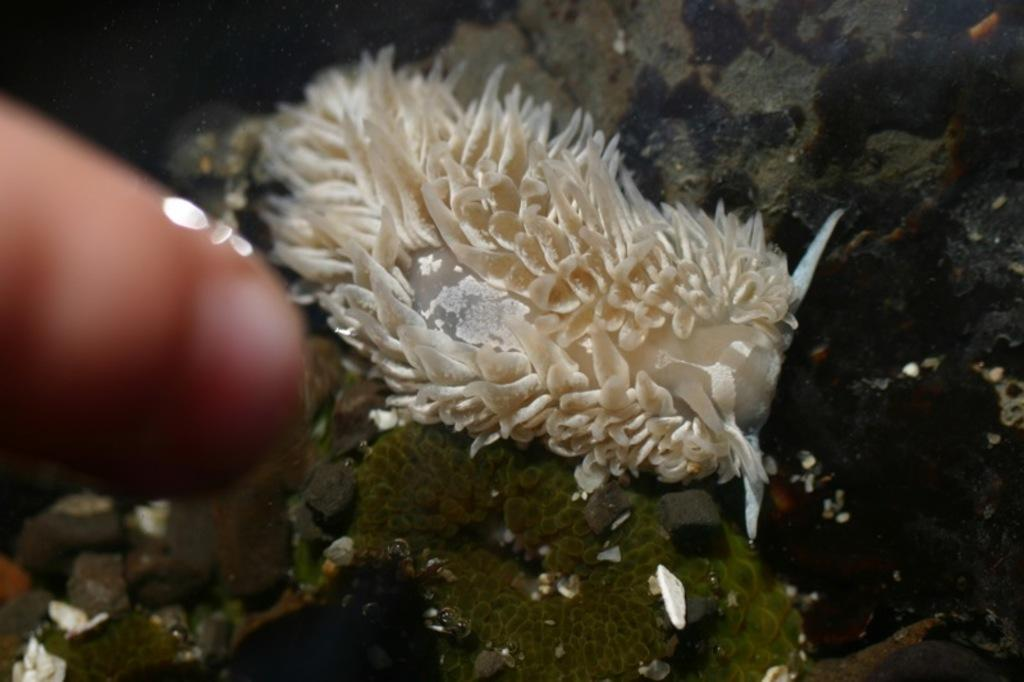What is the perspective of the image? The image is taken from inside the water. What is the main subject in the center of the image? There is a water animal in the center of the image. Can you identify any human presence in the image? Yes, a person's finger is visible in the image. What can be seen at the bottom of the image? There are stones at the bottom of the image. What type of basketball court can be seen in the image? There is no basketball court present in the image; it is taken from inside the water and features a water animal and stones at the bottom. How many pans are visible in the image? There are no pans present in the image. 